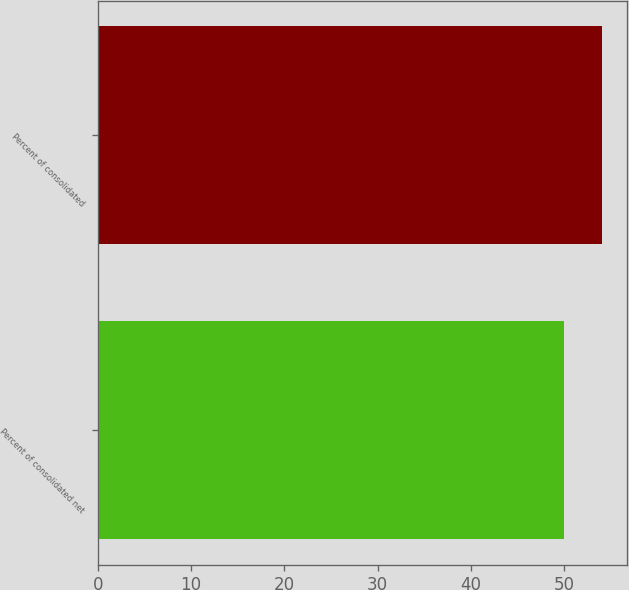Convert chart to OTSL. <chart><loc_0><loc_0><loc_500><loc_500><bar_chart><fcel>Percent of consolidated net<fcel>Percent of consolidated<nl><fcel>50<fcel>54<nl></chart> 